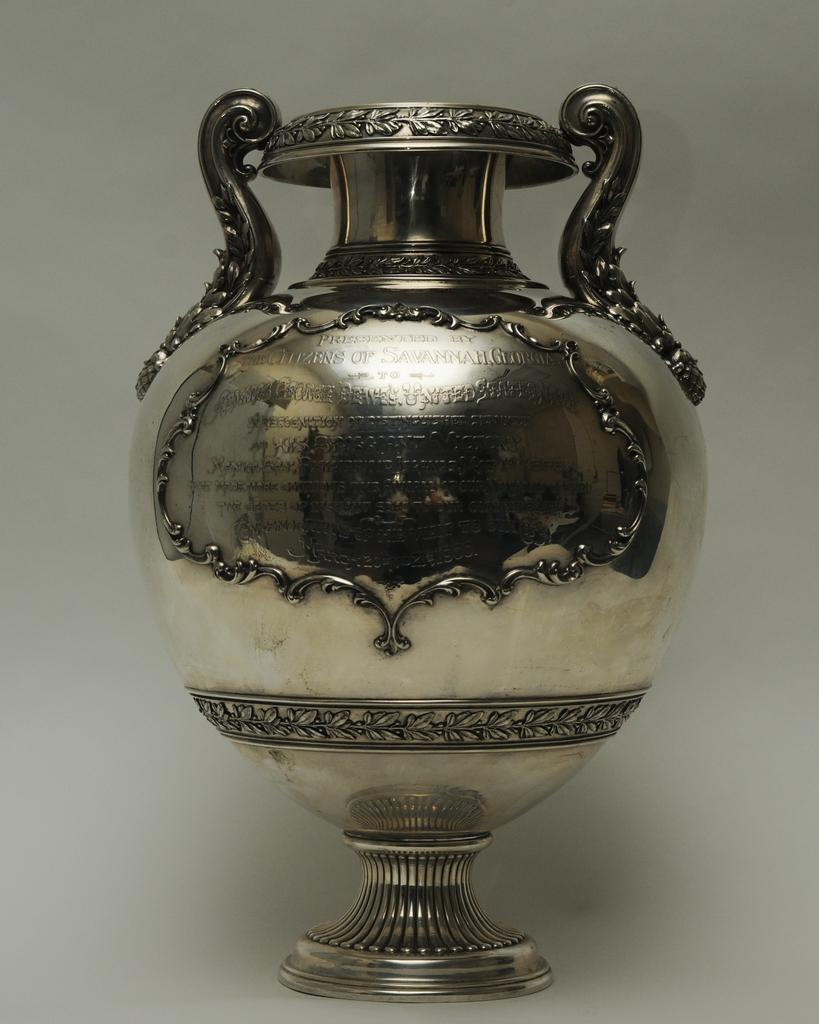What type of object is in the image? There is a metal vase in the image. What can be found on the surface of the vase? There is text on the vase. What color is the background of the image? The background of the image is white. What type of skirt is visible in the image? There is no skirt present in the image; it features a metal vase with text on it against a white background. 